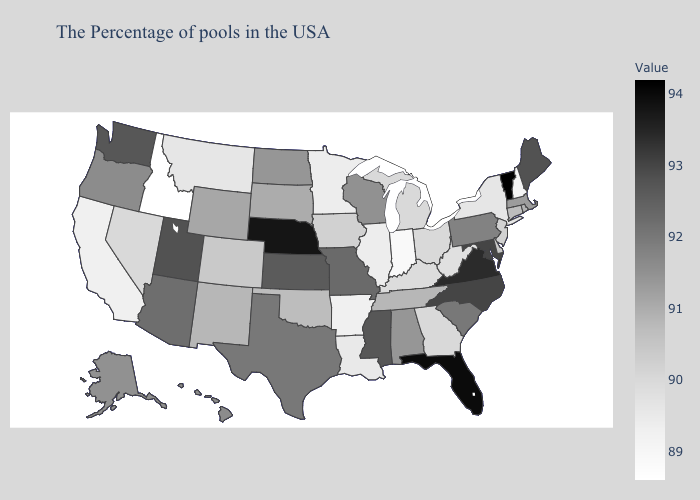Which states have the lowest value in the South?
Keep it brief. Arkansas. Among the states that border Pennsylvania , does New York have the lowest value?
Keep it brief. Yes. Does Nevada have the highest value in the West?
Quick response, please. No. 